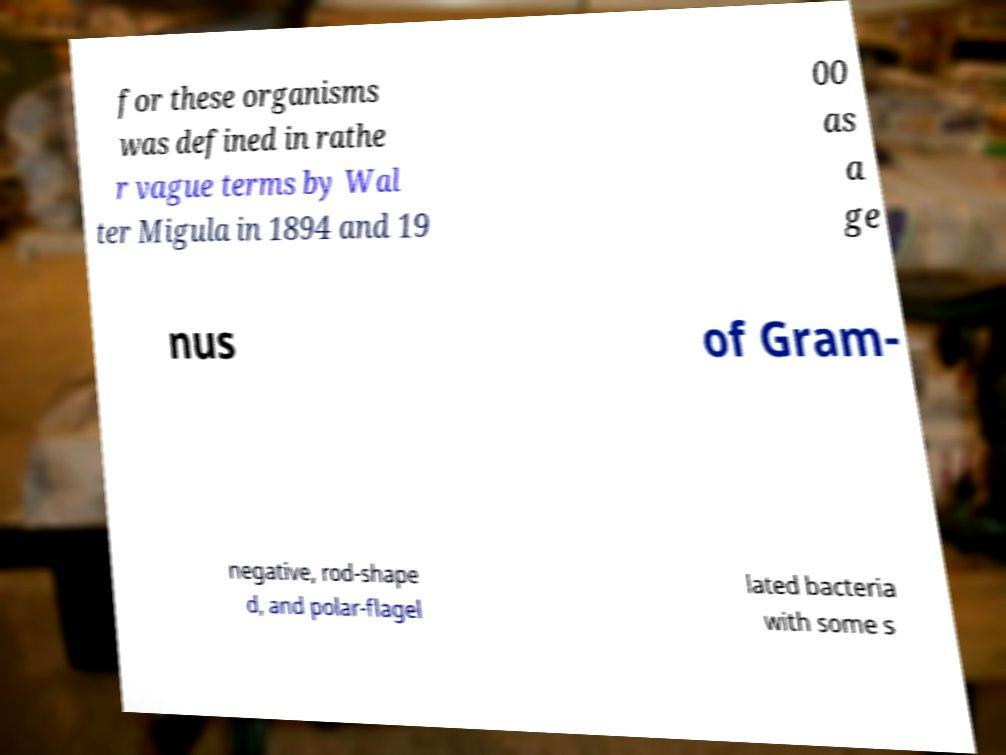There's text embedded in this image that I need extracted. Can you transcribe it verbatim? for these organisms was defined in rathe r vague terms by Wal ter Migula in 1894 and 19 00 as a ge nus of Gram- negative, rod-shape d, and polar-flagel lated bacteria with some s 